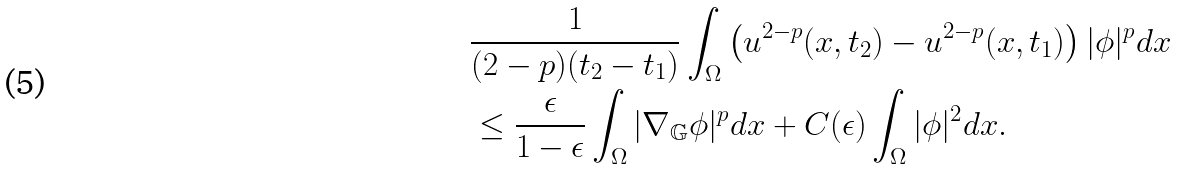Convert formula to latex. <formula><loc_0><loc_0><loc_500><loc_500>& \frac { 1 } { ( 2 - p ) ( t _ { 2 } - t _ { 1 } ) } \int _ { \Omega } \left ( u ^ { 2 - p } ( x , t _ { 2 } ) - u ^ { 2 - p } ( x , t _ { 1 } ) \right ) | \phi | ^ { p } d x \\ & \leq \frac { \epsilon } { 1 - \epsilon } \int _ { \Omega } | \nabla _ { \mathbb { G } } \phi | ^ { p } d x + C ( \epsilon ) \int _ { \Omega } | \phi | ^ { 2 } d x .</formula> 